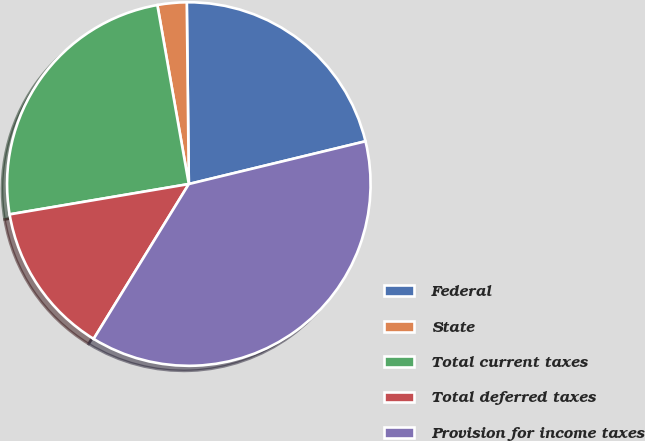Convert chart. <chart><loc_0><loc_0><loc_500><loc_500><pie_chart><fcel>Federal<fcel>State<fcel>Total current taxes<fcel>Total deferred taxes<fcel>Provision for income taxes<nl><fcel>21.4%<fcel>2.59%<fcel>24.9%<fcel>13.56%<fcel>37.55%<nl></chart> 